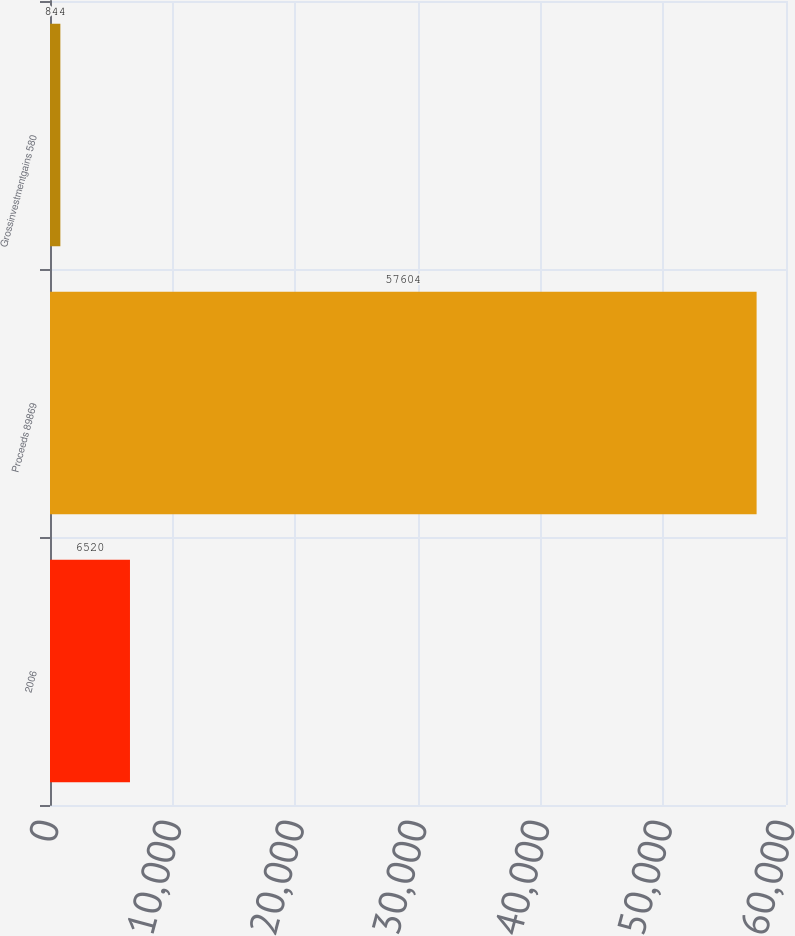Convert chart. <chart><loc_0><loc_0><loc_500><loc_500><bar_chart><fcel>2006<fcel>Proceeds 89869<fcel>Grossinvestmentgains 580<nl><fcel>6520<fcel>57604<fcel>844<nl></chart> 